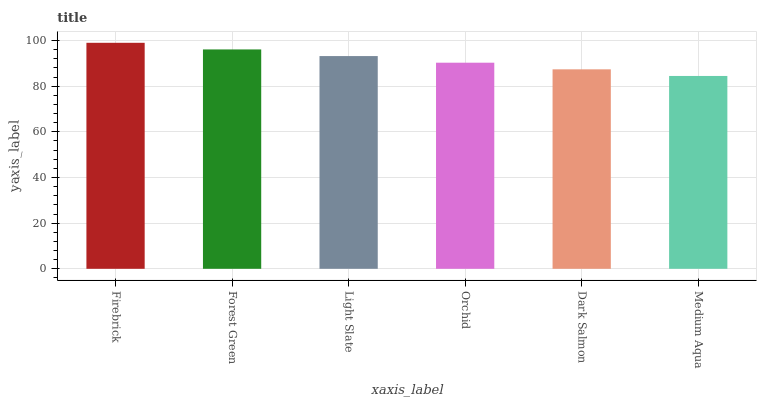Is Medium Aqua the minimum?
Answer yes or no. Yes. Is Firebrick the maximum?
Answer yes or no. Yes. Is Forest Green the minimum?
Answer yes or no. No. Is Forest Green the maximum?
Answer yes or no. No. Is Firebrick greater than Forest Green?
Answer yes or no. Yes. Is Forest Green less than Firebrick?
Answer yes or no. Yes. Is Forest Green greater than Firebrick?
Answer yes or no. No. Is Firebrick less than Forest Green?
Answer yes or no. No. Is Light Slate the high median?
Answer yes or no. Yes. Is Orchid the low median?
Answer yes or no. Yes. Is Forest Green the high median?
Answer yes or no. No. Is Dark Salmon the low median?
Answer yes or no. No. 